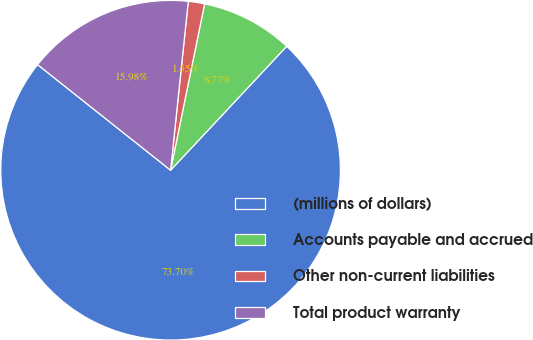Convert chart. <chart><loc_0><loc_0><loc_500><loc_500><pie_chart><fcel>(millions of dollars)<fcel>Accounts payable and accrued<fcel>Other non-current liabilities<fcel>Total product warranty<nl><fcel>73.7%<fcel>8.77%<fcel>1.55%<fcel>15.98%<nl></chart> 